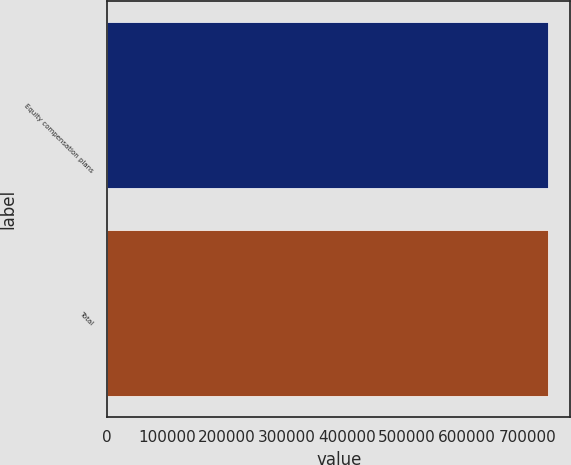Convert chart to OTSL. <chart><loc_0><loc_0><loc_500><loc_500><bar_chart><fcel>Equity compensation plans<fcel>Total<nl><fcel>735297<fcel>735297<nl></chart> 